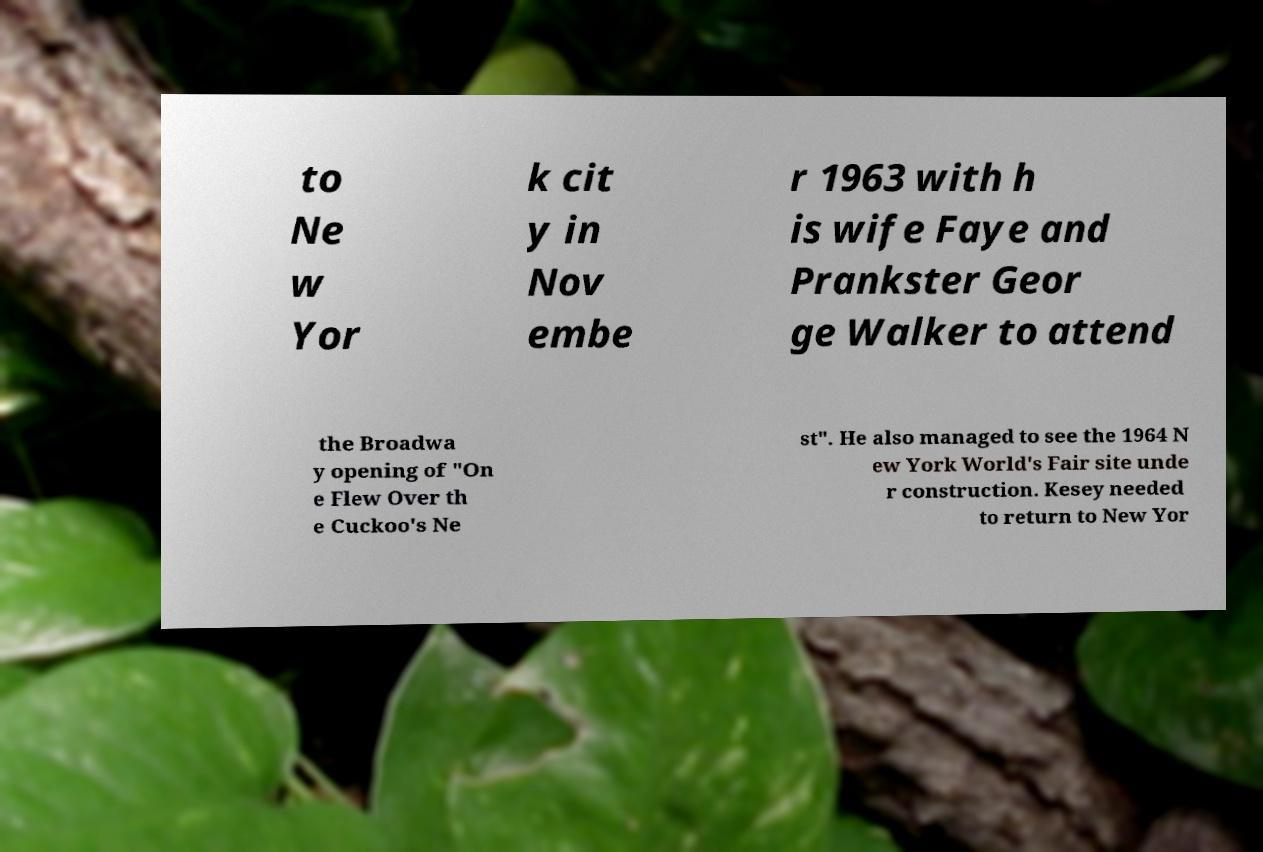Please read and relay the text visible in this image. What does it say? to Ne w Yor k cit y in Nov embe r 1963 with h is wife Faye and Prankster Geor ge Walker to attend the Broadwa y opening of "On e Flew Over th e Cuckoo's Ne st". He also managed to see the 1964 N ew York World's Fair site unde r construction. Kesey needed to return to New Yor 